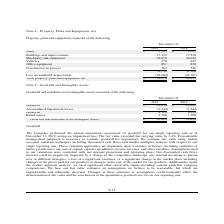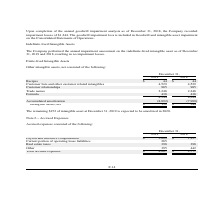According to Lifeway Foods's financial document, What is the value of real estate taxes in 2018? According to the financial document, 398. The relevant text states: "Real estate taxes 398 398..." Also, What is the value of  Payroll and incentive compensation  in 2019? According to the financial document, 3,009. The relevant text states: "Payroll and incentive compensation $ 3,009 $ 1,937..." Also, What is the total accrued expenses in 2019? According to the financial document, 4,087. The relevant text states: "Total accrued expenses $ 4,087 $ 2,777..." Also, can you calculate: What is the average real estate taxes for 2018 and 2019? To answer this question, I need to perform calculations using the financial data. The calculation is: (398+398)/2, which equals 398. This is based on the information: "Real estate taxes 398 398..." Also, can you calculate: What is the change in payroll and incentive compensation between 2018 and 2019? Based on the calculation: 3,009-1,937, the result is 1072. This is based on the information: "Payroll and incentive compensation $ 3,009 $ 1,937 Payroll and incentive compensation $ 3,009 $ 1,937..." The key data points involved are: 1,937, 3,009. Also, can you calculate: What is the percentage change in the total accrued expenses from 2018 to 2019? To answer this question, I need to perform calculations using the financial data. The calculation is: (4,087-2,777)/2,777, which equals 47.17 (percentage). This is based on the information: "Total accrued expenses $ 4,087 $ 2,777 Total accrued expenses $ 4,087 $ 2,777..." The key data points involved are: 2,777, 4,087. 